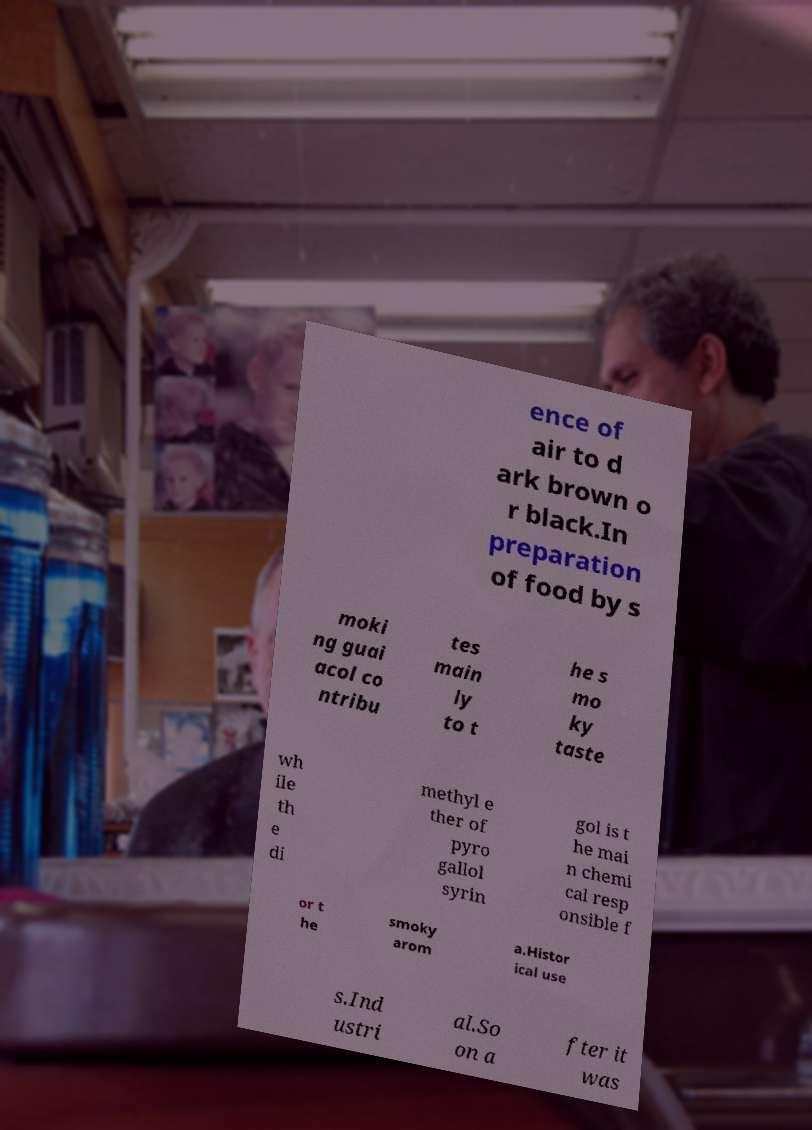Please identify and transcribe the text found in this image. ence of air to d ark brown o r black.In preparation of food by s moki ng guai acol co ntribu tes main ly to t he s mo ky taste wh ile th e di methyl e ther of pyro gallol syrin gol is t he mai n chemi cal resp onsible f or t he smoky arom a.Histor ical use s.Ind ustri al.So on a fter it was 